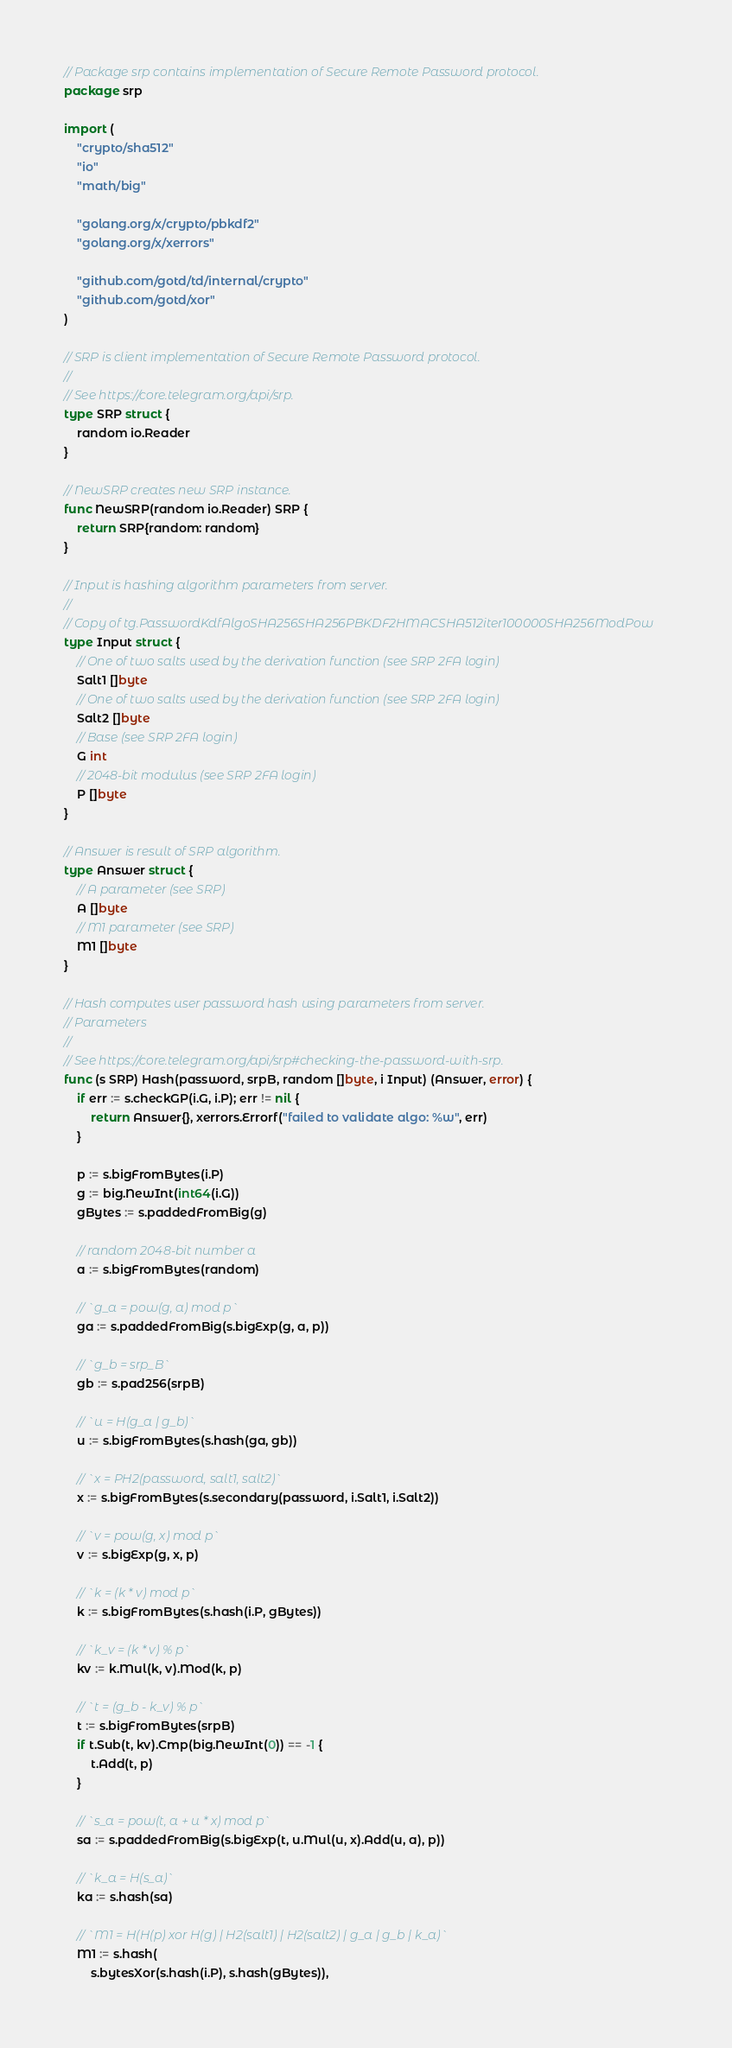<code> <loc_0><loc_0><loc_500><loc_500><_Go_>// Package srp contains implementation of Secure Remote Password protocol.
package srp

import (
	"crypto/sha512"
	"io"
	"math/big"

	"golang.org/x/crypto/pbkdf2"
	"golang.org/x/xerrors"

	"github.com/gotd/td/internal/crypto"
	"github.com/gotd/xor"
)

// SRP is client implementation of Secure Remote Password protocol.
//
// See https://core.telegram.org/api/srp.
type SRP struct {
	random io.Reader
}

// NewSRP creates new SRP instance.
func NewSRP(random io.Reader) SRP {
	return SRP{random: random}
}

// Input is hashing algorithm parameters from server.
//
// Copy of tg.PasswordKdfAlgoSHA256SHA256PBKDF2HMACSHA512iter100000SHA256ModPow
type Input struct {
	// One of two salts used by the derivation function (see SRP 2FA login)
	Salt1 []byte
	// One of two salts used by the derivation function (see SRP 2FA login)
	Salt2 []byte
	// Base (see SRP 2FA login)
	G int
	// 2048-bit modulus (see SRP 2FA login)
	P []byte
}

// Answer is result of SRP algorithm.
type Answer struct {
	// A parameter (see SRP)
	A []byte
	// M1 parameter (see SRP)
	M1 []byte
}

// Hash computes user password hash using parameters from server.
// Parameters
//
// See https://core.telegram.org/api/srp#checking-the-password-with-srp.
func (s SRP) Hash(password, srpB, random []byte, i Input) (Answer, error) {
	if err := s.checkGP(i.G, i.P); err != nil {
		return Answer{}, xerrors.Errorf("failed to validate algo: %w", err)
	}

	p := s.bigFromBytes(i.P)
	g := big.NewInt(int64(i.G))
	gBytes := s.paddedFromBig(g)

	// random 2048-bit number a
	a := s.bigFromBytes(random)

	// `g_a = pow(g, a) mod p`
	ga := s.paddedFromBig(s.bigExp(g, a, p))

	// `g_b = srp_B`
	gb := s.pad256(srpB)

	// `u = H(g_a | g_b)`
	u := s.bigFromBytes(s.hash(ga, gb))

	// `x = PH2(password, salt1, salt2)`
	x := s.bigFromBytes(s.secondary(password, i.Salt1, i.Salt2))

	// `v = pow(g, x) mod p`
	v := s.bigExp(g, x, p)

	// `k = (k * v) mod p`
	k := s.bigFromBytes(s.hash(i.P, gBytes))

	// `k_v = (k * v) % p`
	kv := k.Mul(k, v).Mod(k, p)

	// `t = (g_b - k_v) % p`
	t := s.bigFromBytes(srpB)
	if t.Sub(t, kv).Cmp(big.NewInt(0)) == -1 {
		t.Add(t, p)
	}

	// `s_a = pow(t, a + u * x) mod p`
	sa := s.paddedFromBig(s.bigExp(t, u.Mul(u, x).Add(u, a), p))

	// `k_a = H(s_a)`
	ka := s.hash(sa)

	// `M1 = H(H(p) xor H(g) | H2(salt1) | H2(salt2) | g_a | g_b | k_a)`
	M1 := s.hash(
		s.bytesXor(s.hash(i.P), s.hash(gBytes)),</code> 